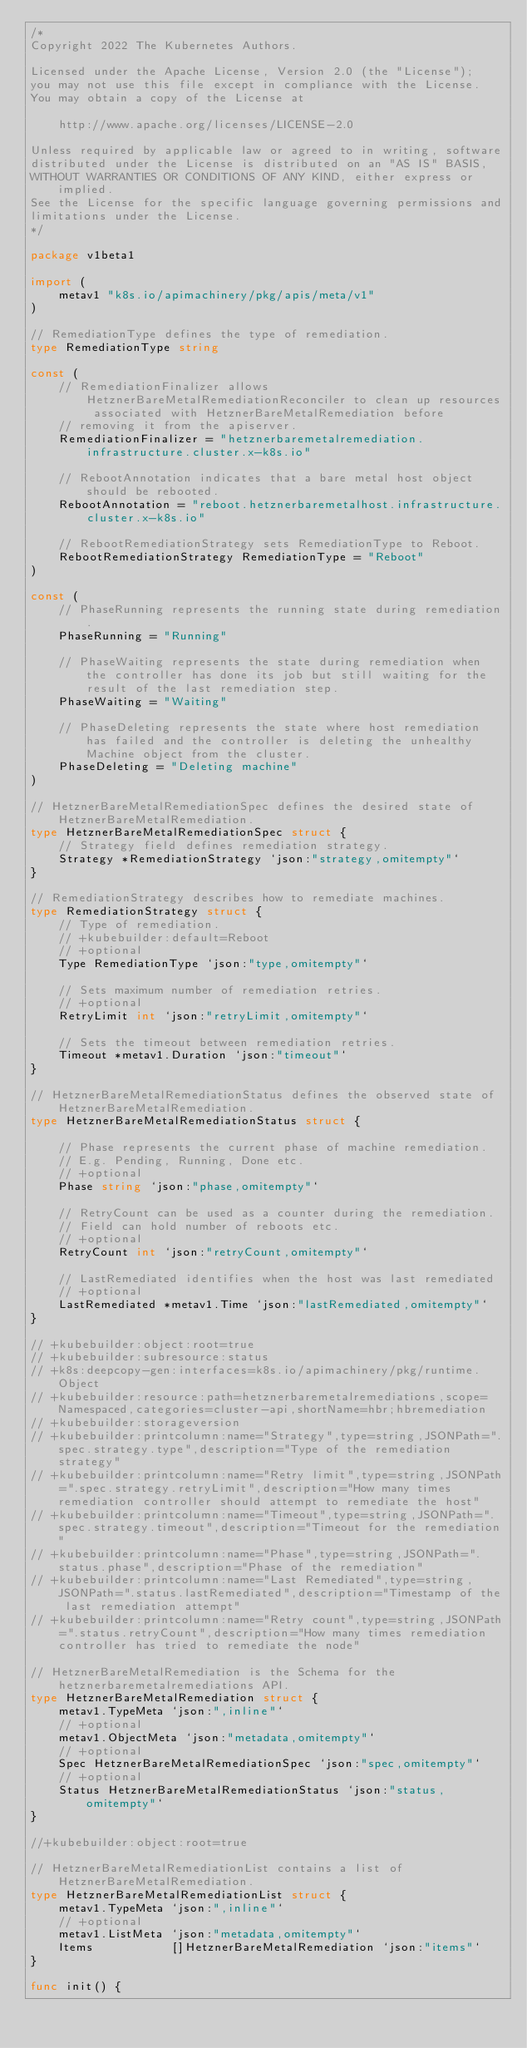<code> <loc_0><loc_0><loc_500><loc_500><_Go_>/*
Copyright 2022 The Kubernetes Authors.

Licensed under the Apache License, Version 2.0 (the "License");
you may not use this file except in compliance with the License.
You may obtain a copy of the License at

    http://www.apache.org/licenses/LICENSE-2.0

Unless required by applicable law or agreed to in writing, software
distributed under the License is distributed on an "AS IS" BASIS,
WITHOUT WARRANTIES OR CONDITIONS OF ANY KIND, either express or implied.
See the License for the specific language governing permissions and
limitations under the License.
*/

package v1beta1

import (
	metav1 "k8s.io/apimachinery/pkg/apis/meta/v1"
)

// RemediationType defines the type of remediation.
type RemediationType string

const (
	// RemediationFinalizer allows HetznerBareMetalRemediationReconciler to clean up resources associated with HetznerBareMetalRemediation before
	// removing it from the apiserver.
	RemediationFinalizer = "hetznerbaremetalremediation.infrastructure.cluster.x-k8s.io"

	// RebootAnnotation indicates that a bare metal host object should be rebooted.
	RebootAnnotation = "reboot.hetznerbaremetalhost.infrastructure.cluster.x-k8s.io"

	// RebootRemediationStrategy sets RemediationType to Reboot.
	RebootRemediationStrategy RemediationType = "Reboot"
)

const (
	// PhaseRunning represents the running state during remediation.
	PhaseRunning = "Running"

	// PhaseWaiting represents the state during remediation when the controller has done its job but still waiting for the result of the last remediation step.
	PhaseWaiting = "Waiting"

	// PhaseDeleting represents the state where host remediation has failed and the controller is deleting the unhealthy Machine object from the cluster.
	PhaseDeleting = "Deleting machine"
)

// HetznerBareMetalRemediationSpec defines the desired state of HetznerBareMetalRemediation.
type HetznerBareMetalRemediationSpec struct {
	// Strategy field defines remediation strategy.
	Strategy *RemediationStrategy `json:"strategy,omitempty"`
}

// RemediationStrategy describes how to remediate machines.
type RemediationStrategy struct {
	// Type of remediation.
	// +kubebuilder:default=Reboot
	// +optional
	Type RemediationType `json:"type,omitempty"`

	// Sets maximum number of remediation retries.
	// +optional
	RetryLimit int `json:"retryLimit,omitempty"`

	// Sets the timeout between remediation retries.
	Timeout *metav1.Duration `json:"timeout"`
}

// HetznerBareMetalRemediationStatus defines the observed state of HetznerBareMetalRemediation.
type HetznerBareMetalRemediationStatus struct {

	// Phase represents the current phase of machine remediation.
	// E.g. Pending, Running, Done etc.
	// +optional
	Phase string `json:"phase,omitempty"`

	// RetryCount can be used as a counter during the remediation.
	// Field can hold number of reboots etc.
	// +optional
	RetryCount int `json:"retryCount,omitempty"`

	// LastRemediated identifies when the host was last remediated
	// +optional
	LastRemediated *metav1.Time `json:"lastRemediated,omitempty"`
}

// +kubebuilder:object:root=true
// +kubebuilder:subresource:status
// +k8s:deepcopy-gen:interfaces=k8s.io/apimachinery/pkg/runtime.Object
// +kubebuilder:resource:path=hetznerbaremetalremediations,scope=Namespaced,categories=cluster-api,shortName=hbr;hbremediation
// +kubebuilder:storageversion
// +kubebuilder:printcolumn:name="Strategy",type=string,JSONPath=".spec.strategy.type",description="Type of the remediation strategy"
// +kubebuilder:printcolumn:name="Retry limit",type=string,JSONPath=".spec.strategy.retryLimit",description="How many times remediation controller should attempt to remediate the host"
// +kubebuilder:printcolumn:name="Timeout",type=string,JSONPath=".spec.strategy.timeout",description="Timeout for the remediation"
// +kubebuilder:printcolumn:name="Phase",type=string,JSONPath=".status.phase",description="Phase of the remediation"
// +kubebuilder:printcolumn:name="Last Remediated",type=string,JSONPath=".status.lastRemediated",description="Timestamp of the last remediation attempt"
// +kubebuilder:printcolumn:name="Retry count",type=string,JSONPath=".status.retryCount",description="How many times remediation controller has tried to remediate the node"

// HetznerBareMetalRemediation is the Schema for the hetznerbaremetalremediations API.
type HetznerBareMetalRemediation struct {
	metav1.TypeMeta `json:",inline"`
	// +optional
	metav1.ObjectMeta `json:"metadata,omitempty"`
	// +optional
	Spec HetznerBareMetalRemediationSpec `json:"spec,omitempty"`
	// +optional
	Status HetznerBareMetalRemediationStatus `json:"status,omitempty"`
}

//+kubebuilder:object:root=true

// HetznerBareMetalRemediationList contains a list of HetznerBareMetalRemediation.
type HetznerBareMetalRemediationList struct {
	metav1.TypeMeta `json:",inline"`
	// +optional
	metav1.ListMeta `json:"metadata,omitempty"`
	Items           []HetznerBareMetalRemediation `json:"items"`
}

func init() {</code> 